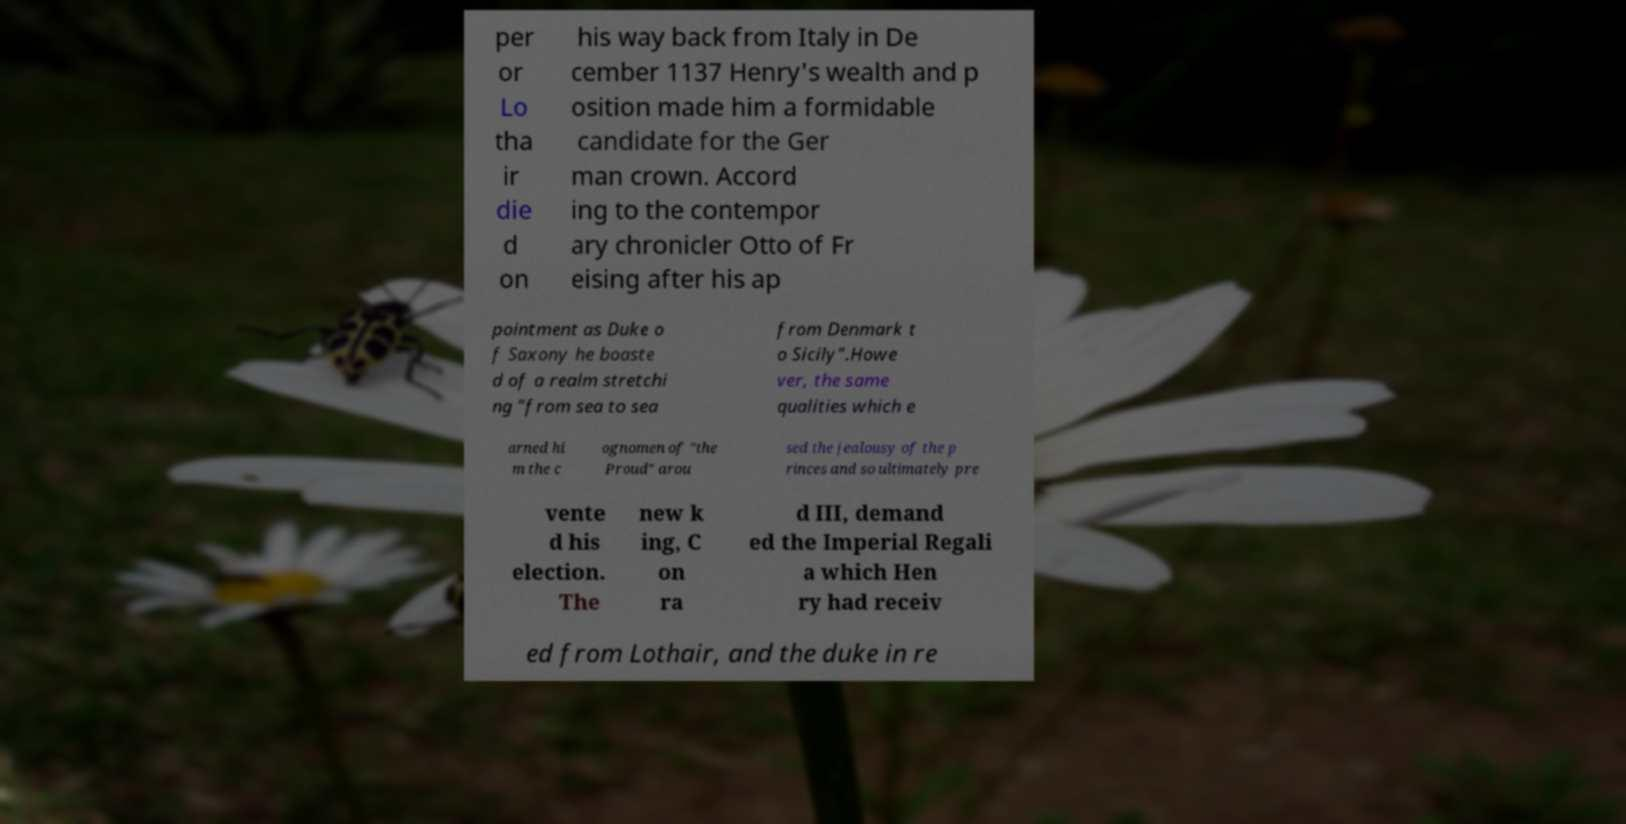Please read and relay the text visible in this image. What does it say? per or Lo tha ir die d on his way back from Italy in De cember 1137 Henry's wealth and p osition made him a formidable candidate for the Ger man crown. Accord ing to the contempor ary chronicler Otto of Fr eising after his ap pointment as Duke o f Saxony he boaste d of a realm stretchi ng "from sea to sea from Denmark t o Sicily".Howe ver, the same qualities which e arned hi m the c ognomen of "the Proud" arou sed the jealousy of the p rinces and so ultimately pre vente d his election. The new k ing, C on ra d III, demand ed the Imperial Regali a which Hen ry had receiv ed from Lothair, and the duke in re 